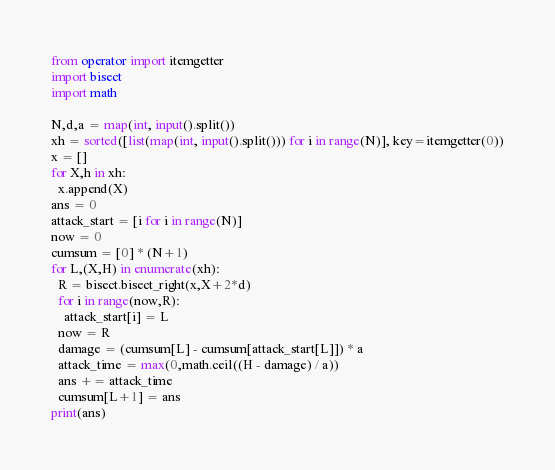Convert code to text. <code><loc_0><loc_0><loc_500><loc_500><_Python_>from operator import itemgetter
import bisect
import math

N,d,a = map(int, input().split())
xh = sorted([list(map(int, input().split())) for i in range(N)], key=itemgetter(0))
x = []
for X,h in xh:
  x.append(X)
ans = 0
attack_start = [i for i in range(N)]
now = 0
cumsum = [0] * (N+1)
for L,(X,H) in enumerate(xh):
  R = bisect.bisect_right(x,X+2*d)
  for i in range(now,R):
    attack_start[i] = L
  now = R
  damage = (cumsum[L] - cumsum[attack_start[L]]) * a
  attack_time = max(0,math.ceil((H - damage) / a))
  ans += attack_time
  cumsum[L+1] = ans
print(ans)

</code> 